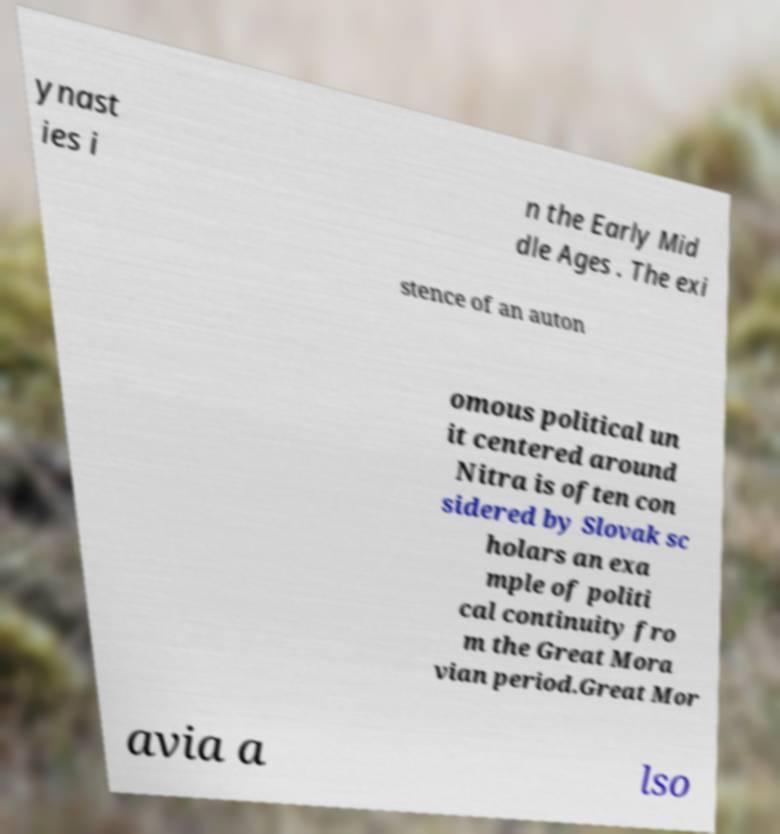What messages or text are displayed in this image? I need them in a readable, typed format. ynast ies i n the Early Mid dle Ages . The exi stence of an auton omous political un it centered around Nitra is often con sidered by Slovak sc holars an exa mple of politi cal continuity fro m the Great Mora vian period.Great Mor avia a lso 